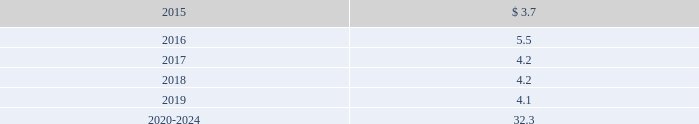Edwards lifesciences corporation notes to consolidated financial statements ( continued ) 12 .
Employee benefit plans ( continued ) equity and debt securities are valued at fair value based on quoted market prices reported on the active markets on which the individual securities are traded .
The insurance contracts are valued at the cash surrender value of the contracts , which is deemed to approximate its fair value .
The following benefit payments , which reflect expected future service , as appropriate , at december 31 , 2014 , are expected to be paid ( in millions ) : .
As of december 31 , 2014 , expected employer contributions for 2015 are $ 5.8 million .
Defined contribution plans the company 2019s employees in the united states and puerto rico are eligible to participate in a qualified 401 ( k ) and 1165 ( e ) plan , respectively .
In the united states , participants may contribute up to 25% ( 25 % ) of their eligible compensation ( subject to tax code limitation ) to the plan .
Edwards lifesciences matches the first 3% ( 3 % ) of the participant 2019s annual eligible compensation contributed to the plan on a dollar-for-dollar basis .
Edwards lifesciences matches the next 2% ( 2 % ) of the participant 2019s annual eligible compensation to the plan on a 50% ( 50 % ) basis .
In puerto rico , participants may contribute up to 25% ( 25 % ) of their annual compensation ( subject to tax code limitation ) to the plan .
Edwards lifesciences matches the first 4% ( 4 % ) of participant 2019s annual eligible compensation contributed to the plan on a 50% ( 50 % ) basis .
The company also provides a 2% ( 2 % ) profit sharing contribution calculated on eligible earnings for each employee .
Matching contributions relating to edwards lifesciences employees were $ 12.8 million , $ 12.0 million , and $ 10.8 million in 2014 , 2013 , and 2012 , respectively .
The company also has nonqualified deferred compensation plans for a select group of employees .
The plans provide eligible participants the opportunity to defer eligible compensation to future dates specified by the participant with a return based on investment alternatives selected by the participant .
The amount accrued under these nonqualified plans was $ 28.7 million and $ 25.9 million at december 31 , 2014 and 2013 , respectively .
13 .
Common stock treasury stock in may 2013 , the board of directors approved a stock repurchase program authorizing the company to purchase up to $ 750.0 million of the company 2019s common stock from time to time until december 31 , 2016 .
In july 2014 , the board of directors approved a new stock repurchase program providing for an additional $ 750.0 million of repurchases without a specified end date .
Stock repurchased under these programs will be used to offset obligations under the company 2019s employee stock option programs and reduce the total shares outstanding .
During 2014 , 2013 , and 2012 , the company repurchased 4.4 million , 6.8 million , and 4.0 million shares , respectively , at an aggregate cost of $ 300.9 million , $ 497.0 million , and $ 353.2 million , respectively , including shares purchased under the accelerated share repurchase ( 2018 2018asr 2019 2019 ) agreements described below and shares .
What was the average purchase price of company repurchased shares in 2013? 
Computations: (497.0 / 6.8)
Answer: 73.08824. 